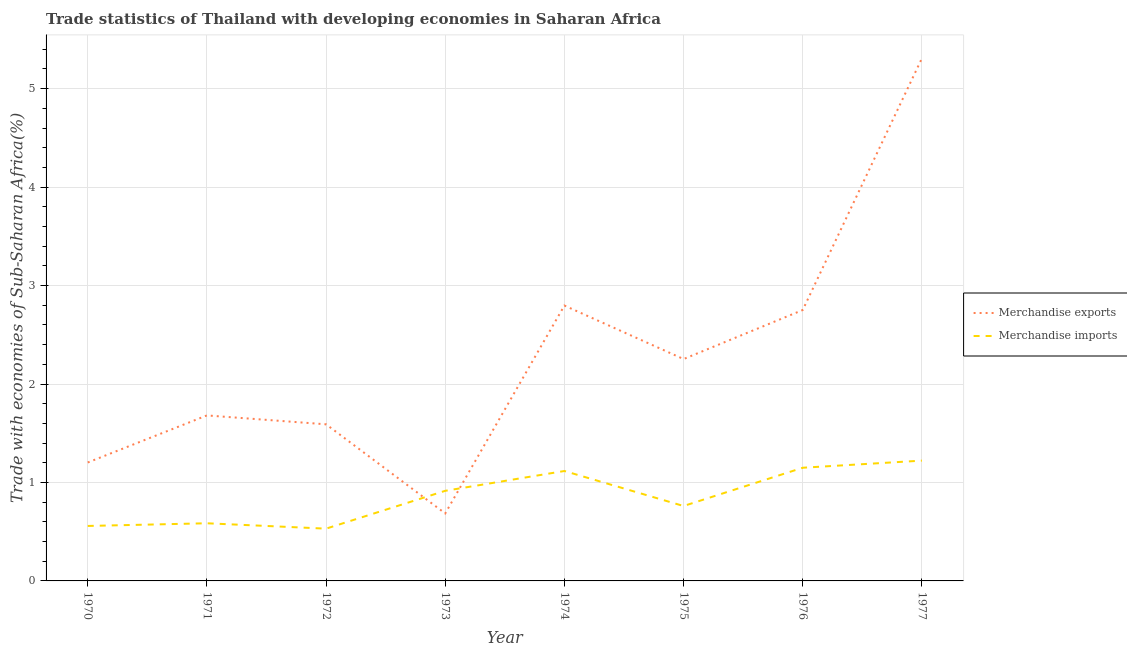How many different coloured lines are there?
Give a very brief answer. 2. Is the number of lines equal to the number of legend labels?
Your answer should be compact. Yes. What is the merchandise imports in 1970?
Ensure brevity in your answer.  0.56. Across all years, what is the maximum merchandise imports?
Offer a terse response. 1.22. Across all years, what is the minimum merchandise imports?
Your response must be concise. 0.53. In which year was the merchandise imports maximum?
Provide a succinct answer. 1977. What is the total merchandise exports in the graph?
Make the answer very short. 18.27. What is the difference between the merchandise imports in 1973 and that in 1975?
Your response must be concise. 0.15. What is the difference between the merchandise exports in 1976 and the merchandise imports in 1977?
Ensure brevity in your answer.  1.53. What is the average merchandise exports per year?
Your response must be concise. 2.28. In the year 1977, what is the difference between the merchandise imports and merchandise exports?
Offer a terse response. -4.09. In how many years, is the merchandise exports greater than 4 %?
Keep it short and to the point. 1. What is the ratio of the merchandise imports in 1970 to that in 1972?
Offer a terse response. 1.05. Is the merchandise imports in 1974 less than that in 1976?
Provide a short and direct response. Yes. Is the difference between the merchandise imports in 1973 and 1974 greater than the difference between the merchandise exports in 1973 and 1974?
Your answer should be compact. Yes. What is the difference between the highest and the second highest merchandise imports?
Your answer should be very brief. 0.07. What is the difference between the highest and the lowest merchandise exports?
Offer a terse response. 4.62. In how many years, is the merchandise imports greater than the average merchandise imports taken over all years?
Offer a terse response. 4. Does the merchandise imports monotonically increase over the years?
Provide a short and direct response. No. Is the merchandise exports strictly less than the merchandise imports over the years?
Your answer should be compact. No. How many lines are there?
Keep it short and to the point. 2. What is the difference between two consecutive major ticks on the Y-axis?
Make the answer very short. 1. Are the values on the major ticks of Y-axis written in scientific E-notation?
Provide a short and direct response. No. Does the graph contain any zero values?
Provide a short and direct response. No. Does the graph contain grids?
Your response must be concise. Yes. How many legend labels are there?
Offer a very short reply. 2. What is the title of the graph?
Your response must be concise. Trade statistics of Thailand with developing economies in Saharan Africa. What is the label or title of the Y-axis?
Your answer should be very brief. Trade with economies of Sub-Saharan Africa(%). What is the Trade with economies of Sub-Saharan Africa(%) of Merchandise exports in 1970?
Provide a succinct answer. 1.2. What is the Trade with economies of Sub-Saharan Africa(%) of Merchandise imports in 1970?
Keep it short and to the point. 0.56. What is the Trade with economies of Sub-Saharan Africa(%) in Merchandise exports in 1971?
Offer a terse response. 1.68. What is the Trade with economies of Sub-Saharan Africa(%) in Merchandise imports in 1971?
Keep it short and to the point. 0.59. What is the Trade with economies of Sub-Saharan Africa(%) in Merchandise exports in 1972?
Offer a very short reply. 1.59. What is the Trade with economies of Sub-Saharan Africa(%) in Merchandise imports in 1972?
Your answer should be compact. 0.53. What is the Trade with economies of Sub-Saharan Africa(%) of Merchandise exports in 1973?
Your response must be concise. 0.69. What is the Trade with economies of Sub-Saharan Africa(%) of Merchandise imports in 1973?
Ensure brevity in your answer.  0.92. What is the Trade with economies of Sub-Saharan Africa(%) of Merchandise exports in 1974?
Provide a succinct answer. 2.8. What is the Trade with economies of Sub-Saharan Africa(%) in Merchandise imports in 1974?
Ensure brevity in your answer.  1.12. What is the Trade with economies of Sub-Saharan Africa(%) of Merchandise exports in 1975?
Ensure brevity in your answer.  2.25. What is the Trade with economies of Sub-Saharan Africa(%) of Merchandise imports in 1975?
Give a very brief answer. 0.76. What is the Trade with economies of Sub-Saharan Africa(%) of Merchandise exports in 1976?
Provide a succinct answer. 2.75. What is the Trade with economies of Sub-Saharan Africa(%) of Merchandise imports in 1976?
Provide a short and direct response. 1.15. What is the Trade with economies of Sub-Saharan Africa(%) of Merchandise exports in 1977?
Make the answer very short. 5.31. What is the Trade with economies of Sub-Saharan Africa(%) of Merchandise imports in 1977?
Your response must be concise. 1.22. Across all years, what is the maximum Trade with economies of Sub-Saharan Africa(%) of Merchandise exports?
Your response must be concise. 5.31. Across all years, what is the maximum Trade with economies of Sub-Saharan Africa(%) in Merchandise imports?
Provide a short and direct response. 1.22. Across all years, what is the minimum Trade with economies of Sub-Saharan Africa(%) in Merchandise exports?
Your answer should be compact. 0.69. Across all years, what is the minimum Trade with economies of Sub-Saharan Africa(%) in Merchandise imports?
Give a very brief answer. 0.53. What is the total Trade with economies of Sub-Saharan Africa(%) in Merchandise exports in the graph?
Provide a short and direct response. 18.27. What is the total Trade with economies of Sub-Saharan Africa(%) in Merchandise imports in the graph?
Your response must be concise. 6.84. What is the difference between the Trade with economies of Sub-Saharan Africa(%) in Merchandise exports in 1970 and that in 1971?
Keep it short and to the point. -0.48. What is the difference between the Trade with economies of Sub-Saharan Africa(%) of Merchandise imports in 1970 and that in 1971?
Offer a very short reply. -0.03. What is the difference between the Trade with economies of Sub-Saharan Africa(%) of Merchandise exports in 1970 and that in 1972?
Your answer should be compact. -0.39. What is the difference between the Trade with economies of Sub-Saharan Africa(%) of Merchandise imports in 1970 and that in 1972?
Keep it short and to the point. 0.03. What is the difference between the Trade with economies of Sub-Saharan Africa(%) in Merchandise exports in 1970 and that in 1973?
Your answer should be compact. 0.52. What is the difference between the Trade with economies of Sub-Saharan Africa(%) of Merchandise imports in 1970 and that in 1973?
Offer a terse response. -0.36. What is the difference between the Trade with economies of Sub-Saharan Africa(%) of Merchandise exports in 1970 and that in 1974?
Your answer should be very brief. -1.59. What is the difference between the Trade with economies of Sub-Saharan Africa(%) in Merchandise imports in 1970 and that in 1974?
Provide a short and direct response. -0.56. What is the difference between the Trade with economies of Sub-Saharan Africa(%) in Merchandise exports in 1970 and that in 1975?
Your response must be concise. -1.05. What is the difference between the Trade with economies of Sub-Saharan Africa(%) in Merchandise imports in 1970 and that in 1975?
Provide a succinct answer. -0.2. What is the difference between the Trade with economies of Sub-Saharan Africa(%) of Merchandise exports in 1970 and that in 1976?
Offer a terse response. -1.55. What is the difference between the Trade with economies of Sub-Saharan Africa(%) of Merchandise imports in 1970 and that in 1976?
Your response must be concise. -0.59. What is the difference between the Trade with economies of Sub-Saharan Africa(%) in Merchandise exports in 1970 and that in 1977?
Your response must be concise. -4.1. What is the difference between the Trade with economies of Sub-Saharan Africa(%) of Merchandise imports in 1970 and that in 1977?
Offer a terse response. -0.66. What is the difference between the Trade with economies of Sub-Saharan Africa(%) of Merchandise exports in 1971 and that in 1972?
Provide a short and direct response. 0.09. What is the difference between the Trade with economies of Sub-Saharan Africa(%) in Merchandise imports in 1971 and that in 1972?
Your answer should be very brief. 0.05. What is the difference between the Trade with economies of Sub-Saharan Africa(%) in Merchandise imports in 1971 and that in 1973?
Ensure brevity in your answer.  -0.33. What is the difference between the Trade with economies of Sub-Saharan Africa(%) in Merchandise exports in 1971 and that in 1974?
Offer a very short reply. -1.12. What is the difference between the Trade with economies of Sub-Saharan Africa(%) in Merchandise imports in 1971 and that in 1974?
Your response must be concise. -0.53. What is the difference between the Trade with economies of Sub-Saharan Africa(%) of Merchandise exports in 1971 and that in 1975?
Ensure brevity in your answer.  -0.57. What is the difference between the Trade with economies of Sub-Saharan Africa(%) of Merchandise imports in 1971 and that in 1975?
Keep it short and to the point. -0.18. What is the difference between the Trade with economies of Sub-Saharan Africa(%) in Merchandise exports in 1971 and that in 1976?
Provide a succinct answer. -1.07. What is the difference between the Trade with economies of Sub-Saharan Africa(%) in Merchandise imports in 1971 and that in 1976?
Your answer should be compact. -0.56. What is the difference between the Trade with economies of Sub-Saharan Africa(%) of Merchandise exports in 1971 and that in 1977?
Ensure brevity in your answer.  -3.63. What is the difference between the Trade with economies of Sub-Saharan Africa(%) in Merchandise imports in 1971 and that in 1977?
Offer a very short reply. -0.64. What is the difference between the Trade with economies of Sub-Saharan Africa(%) of Merchandise exports in 1972 and that in 1973?
Offer a very short reply. 0.91. What is the difference between the Trade with economies of Sub-Saharan Africa(%) in Merchandise imports in 1972 and that in 1973?
Offer a terse response. -0.38. What is the difference between the Trade with economies of Sub-Saharan Africa(%) of Merchandise exports in 1972 and that in 1974?
Offer a very short reply. -1.21. What is the difference between the Trade with economies of Sub-Saharan Africa(%) in Merchandise imports in 1972 and that in 1974?
Offer a very short reply. -0.59. What is the difference between the Trade with economies of Sub-Saharan Africa(%) in Merchandise exports in 1972 and that in 1975?
Ensure brevity in your answer.  -0.66. What is the difference between the Trade with economies of Sub-Saharan Africa(%) of Merchandise imports in 1972 and that in 1975?
Give a very brief answer. -0.23. What is the difference between the Trade with economies of Sub-Saharan Africa(%) in Merchandise exports in 1972 and that in 1976?
Provide a short and direct response. -1.16. What is the difference between the Trade with economies of Sub-Saharan Africa(%) in Merchandise imports in 1972 and that in 1976?
Provide a short and direct response. -0.62. What is the difference between the Trade with economies of Sub-Saharan Africa(%) in Merchandise exports in 1972 and that in 1977?
Provide a short and direct response. -3.72. What is the difference between the Trade with economies of Sub-Saharan Africa(%) of Merchandise imports in 1972 and that in 1977?
Your answer should be very brief. -0.69. What is the difference between the Trade with economies of Sub-Saharan Africa(%) in Merchandise exports in 1973 and that in 1974?
Provide a succinct answer. -2.11. What is the difference between the Trade with economies of Sub-Saharan Africa(%) in Merchandise imports in 1973 and that in 1974?
Provide a succinct answer. -0.2. What is the difference between the Trade with economies of Sub-Saharan Africa(%) in Merchandise exports in 1973 and that in 1975?
Provide a succinct answer. -1.57. What is the difference between the Trade with economies of Sub-Saharan Africa(%) of Merchandise imports in 1973 and that in 1975?
Offer a very short reply. 0.15. What is the difference between the Trade with economies of Sub-Saharan Africa(%) of Merchandise exports in 1973 and that in 1976?
Offer a very short reply. -2.07. What is the difference between the Trade with economies of Sub-Saharan Africa(%) of Merchandise imports in 1973 and that in 1976?
Provide a succinct answer. -0.23. What is the difference between the Trade with economies of Sub-Saharan Africa(%) of Merchandise exports in 1973 and that in 1977?
Provide a succinct answer. -4.62. What is the difference between the Trade with economies of Sub-Saharan Africa(%) of Merchandise imports in 1973 and that in 1977?
Give a very brief answer. -0.31. What is the difference between the Trade with economies of Sub-Saharan Africa(%) of Merchandise exports in 1974 and that in 1975?
Provide a short and direct response. 0.54. What is the difference between the Trade with economies of Sub-Saharan Africa(%) in Merchandise imports in 1974 and that in 1975?
Provide a short and direct response. 0.36. What is the difference between the Trade with economies of Sub-Saharan Africa(%) in Merchandise exports in 1974 and that in 1976?
Keep it short and to the point. 0.05. What is the difference between the Trade with economies of Sub-Saharan Africa(%) of Merchandise imports in 1974 and that in 1976?
Ensure brevity in your answer.  -0.03. What is the difference between the Trade with economies of Sub-Saharan Africa(%) in Merchandise exports in 1974 and that in 1977?
Ensure brevity in your answer.  -2.51. What is the difference between the Trade with economies of Sub-Saharan Africa(%) in Merchandise imports in 1974 and that in 1977?
Provide a succinct answer. -0.11. What is the difference between the Trade with economies of Sub-Saharan Africa(%) in Merchandise exports in 1975 and that in 1976?
Keep it short and to the point. -0.5. What is the difference between the Trade with economies of Sub-Saharan Africa(%) in Merchandise imports in 1975 and that in 1976?
Keep it short and to the point. -0.39. What is the difference between the Trade with economies of Sub-Saharan Africa(%) of Merchandise exports in 1975 and that in 1977?
Offer a terse response. -3.05. What is the difference between the Trade with economies of Sub-Saharan Africa(%) in Merchandise imports in 1975 and that in 1977?
Provide a succinct answer. -0.46. What is the difference between the Trade with economies of Sub-Saharan Africa(%) of Merchandise exports in 1976 and that in 1977?
Your answer should be compact. -2.56. What is the difference between the Trade with economies of Sub-Saharan Africa(%) in Merchandise imports in 1976 and that in 1977?
Ensure brevity in your answer.  -0.07. What is the difference between the Trade with economies of Sub-Saharan Africa(%) in Merchandise exports in 1970 and the Trade with economies of Sub-Saharan Africa(%) in Merchandise imports in 1971?
Give a very brief answer. 0.62. What is the difference between the Trade with economies of Sub-Saharan Africa(%) in Merchandise exports in 1970 and the Trade with economies of Sub-Saharan Africa(%) in Merchandise imports in 1972?
Provide a short and direct response. 0.67. What is the difference between the Trade with economies of Sub-Saharan Africa(%) of Merchandise exports in 1970 and the Trade with economies of Sub-Saharan Africa(%) of Merchandise imports in 1973?
Ensure brevity in your answer.  0.29. What is the difference between the Trade with economies of Sub-Saharan Africa(%) of Merchandise exports in 1970 and the Trade with economies of Sub-Saharan Africa(%) of Merchandise imports in 1974?
Offer a terse response. 0.09. What is the difference between the Trade with economies of Sub-Saharan Africa(%) of Merchandise exports in 1970 and the Trade with economies of Sub-Saharan Africa(%) of Merchandise imports in 1975?
Provide a succinct answer. 0.44. What is the difference between the Trade with economies of Sub-Saharan Africa(%) of Merchandise exports in 1970 and the Trade with economies of Sub-Saharan Africa(%) of Merchandise imports in 1976?
Provide a short and direct response. 0.05. What is the difference between the Trade with economies of Sub-Saharan Africa(%) of Merchandise exports in 1970 and the Trade with economies of Sub-Saharan Africa(%) of Merchandise imports in 1977?
Provide a short and direct response. -0.02. What is the difference between the Trade with economies of Sub-Saharan Africa(%) in Merchandise exports in 1971 and the Trade with economies of Sub-Saharan Africa(%) in Merchandise imports in 1972?
Your answer should be very brief. 1.15. What is the difference between the Trade with economies of Sub-Saharan Africa(%) of Merchandise exports in 1971 and the Trade with economies of Sub-Saharan Africa(%) of Merchandise imports in 1973?
Make the answer very short. 0.77. What is the difference between the Trade with economies of Sub-Saharan Africa(%) of Merchandise exports in 1971 and the Trade with economies of Sub-Saharan Africa(%) of Merchandise imports in 1974?
Your answer should be compact. 0.56. What is the difference between the Trade with economies of Sub-Saharan Africa(%) of Merchandise exports in 1971 and the Trade with economies of Sub-Saharan Africa(%) of Merchandise imports in 1975?
Your response must be concise. 0.92. What is the difference between the Trade with economies of Sub-Saharan Africa(%) of Merchandise exports in 1971 and the Trade with economies of Sub-Saharan Africa(%) of Merchandise imports in 1976?
Your response must be concise. 0.53. What is the difference between the Trade with economies of Sub-Saharan Africa(%) of Merchandise exports in 1971 and the Trade with economies of Sub-Saharan Africa(%) of Merchandise imports in 1977?
Keep it short and to the point. 0.46. What is the difference between the Trade with economies of Sub-Saharan Africa(%) of Merchandise exports in 1972 and the Trade with economies of Sub-Saharan Africa(%) of Merchandise imports in 1973?
Keep it short and to the point. 0.68. What is the difference between the Trade with economies of Sub-Saharan Africa(%) of Merchandise exports in 1972 and the Trade with economies of Sub-Saharan Africa(%) of Merchandise imports in 1974?
Give a very brief answer. 0.47. What is the difference between the Trade with economies of Sub-Saharan Africa(%) in Merchandise exports in 1972 and the Trade with economies of Sub-Saharan Africa(%) in Merchandise imports in 1975?
Keep it short and to the point. 0.83. What is the difference between the Trade with economies of Sub-Saharan Africa(%) in Merchandise exports in 1972 and the Trade with economies of Sub-Saharan Africa(%) in Merchandise imports in 1976?
Your answer should be very brief. 0.44. What is the difference between the Trade with economies of Sub-Saharan Africa(%) in Merchandise exports in 1972 and the Trade with economies of Sub-Saharan Africa(%) in Merchandise imports in 1977?
Your response must be concise. 0.37. What is the difference between the Trade with economies of Sub-Saharan Africa(%) of Merchandise exports in 1973 and the Trade with economies of Sub-Saharan Africa(%) of Merchandise imports in 1974?
Make the answer very short. -0.43. What is the difference between the Trade with economies of Sub-Saharan Africa(%) in Merchandise exports in 1973 and the Trade with economies of Sub-Saharan Africa(%) in Merchandise imports in 1975?
Provide a short and direct response. -0.08. What is the difference between the Trade with economies of Sub-Saharan Africa(%) of Merchandise exports in 1973 and the Trade with economies of Sub-Saharan Africa(%) of Merchandise imports in 1976?
Your response must be concise. -0.46. What is the difference between the Trade with economies of Sub-Saharan Africa(%) in Merchandise exports in 1973 and the Trade with economies of Sub-Saharan Africa(%) in Merchandise imports in 1977?
Provide a short and direct response. -0.54. What is the difference between the Trade with economies of Sub-Saharan Africa(%) in Merchandise exports in 1974 and the Trade with economies of Sub-Saharan Africa(%) in Merchandise imports in 1975?
Give a very brief answer. 2.04. What is the difference between the Trade with economies of Sub-Saharan Africa(%) of Merchandise exports in 1974 and the Trade with economies of Sub-Saharan Africa(%) of Merchandise imports in 1976?
Provide a succinct answer. 1.65. What is the difference between the Trade with economies of Sub-Saharan Africa(%) in Merchandise exports in 1974 and the Trade with economies of Sub-Saharan Africa(%) in Merchandise imports in 1977?
Offer a very short reply. 1.57. What is the difference between the Trade with economies of Sub-Saharan Africa(%) of Merchandise exports in 1975 and the Trade with economies of Sub-Saharan Africa(%) of Merchandise imports in 1976?
Provide a short and direct response. 1.1. What is the difference between the Trade with economies of Sub-Saharan Africa(%) of Merchandise exports in 1975 and the Trade with economies of Sub-Saharan Africa(%) of Merchandise imports in 1977?
Your response must be concise. 1.03. What is the difference between the Trade with economies of Sub-Saharan Africa(%) in Merchandise exports in 1976 and the Trade with economies of Sub-Saharan Africa(%) in Merchandise imports in 1977?
Your response must be concise. 1.53. What is the average Trade with economies of Sub-Saharan Africa(%) of Merchandise exports per year?
Your answer should be compact. 2.28. What is the average Trade with economies of Sub-Saharan Africa(%) of Merchandise imports per year?
Your answer should be compact. 0.85. In the year 1970, what is the difference between the Trade with economies of Sub-Saharan Africa(%) of Merchandise exports and Trade with economies of Sub-Saharan Africa(%) of Merchandise imports?
Provide a short and direct response. 0.64. In the year 1971, what is the difference between the Trade with economies of Sub-Saharan Africa(%) in Merchandise exports and Trade with economies of Sub-Saharan Africa(%) in Merchandise imports?
Provide a short and direct response. 1.1. In the year 1972, what is the difference between the Trade with economies of Sub-Saharan Africa(%) of Merchandise exports and Trade with economies of Sub-Saharan Africa(%) of Merchandise imports?
Your response must be concise. 1.06. In the year 1973, what is the difference between the Trade with economies of Sub-Saharan Africa(%) of Merchandise exports and Trade with economies of Sub-Saharan Africa(%) of Merchandise imports?
Keep it short and to the point. -0.23. In the year 1974, what is the difference between the Trade with economies of Sub-Saharan Africa(%) of Merchandise exports and Trade with economies of Sub-Saharan Africa(%) of Merchandise imports?
Provide a succinct answer. 1.68. In the year 1975, what is the difference between the Trade with economies of Sub-Saharan Africa(%) of Merchandise exports and Trade with economies of Sub-Saharan Africa(%) of Merchandise imports?
Your response must be concise. 1.49. In the year 1976, what is the difference between the Trade with economies of Sub-Saharan Africa(%) of Merchandise exports and Trade with economies of Sub-Saharan Africa(%) of Merchandise imports?
Provide a succinct answer. 1.6. In the year 1977, what is the difference between the Trade with economies of Sub-Saharan Africa(%) in Merchandise exports and Trade with economies of Sub-Saharan Africa(%) in Merchandise imports?
Make the answer very short. 4.09. What is the ratio of the Trade with economies of Sub-Saharan Africa(%) of Merchandise exports in 1970 to that in 1971?
Your answer should be very brief. 0.72. What is the ratio of the Trade with economies of Sub-Saharan Africa(%) in Merchandise imports in 1970 to that in 1971?
Give a very brief answer. 0.95. What is the ratio of the Trade with economies of Sub-Saharan Africa(%) in Merchandise exports in 1970 to that in 1972?
Your response must be concise. 0.76. What is the ratio of the Trade with economies of Sub-Saharan Africa(%) of Merchandise imports in 1970 to that in 1972?
Your response must be concise. 1.05. What is the ratio of the Trade with economies of Sub-Saharan Africa(%) of Merchandise exports in 1970 to that in 1973?
Your answer should be very brief. 1.75. What is the ratio of the Trade with economies of Sub-Saharan Africa(%) of Merchandise imports in 1970 to that in 1973?
Offer a very short reply. 0.61. What is the ratio of the Trade with economies of Sub-Saharan Africa(%) in Merchandise exports in 1970 to that in 1974?
Make the answer very short. 0.43. What is the ratio of the Trade with economies of Sub-Saharan Africa(%) of Merchandise imports in 1970 to that in 1974?
Your answer should be compact. 0.5. What is the ratio of the Trade with economies of Sub-Saharan Africa(%) in Merchandise exports in 1970 to that in 1975?
Provide a succinct answer. 0.53. What is the ratio of the Trade with economies of Sub-Saharan Africa(%) in Merchandise imports in 1970 to that in 1975?
Offer a terse response. 0.73. What is the ratio of the Trade with economies of Sub-Saharan Africa(%) of Merchandise exports in 1970 to that in 1976?
Your response must be concise. 0.44. What is the ratio of the Trade with economies of Sub-Saharan Africa(%) in Merchandise imports in 1970 to that in 1976?
Keep it short and to the point. 0.49. What is the ratio of the Trade with economies of Sub-Saharan Africa(%) of Merchandise exports in 1970 to that in 1977?
Give a very brief answer. 0.23. What is the ratio of the Trade with economies of Sub-Saharan Africa(%) in Merchandise imports in 1970 to that in 1977?
Provide a succinct answer. 0.46. What is the ratio of the Trade with economies of Sub-Saharan Africa(%) of Merchandise exports in 1971 to that in 1972?
Provide a short and direct response. 1.06. What is the ratio of the Trade with economies of Sub-Saharan Africa(%) in Merchandise imports in 1971 to that in 1972?
Keep it short and to the point. 1.1. What is the ratio of the Trade with economies of Sub-Saharan Africa(%) in Merchandise exports in 1971 to that in 1973?
Your answer should be compact. 2.45. What is the ratio of the Trade with economies of Sub-Saharan Africa(%) in Merchandise imports in 1971 to that in 1973?
Offer a terse response. 0.64. What is the ratio of the Trade with economies of Sub-Saharan Africa(%) in Merchandise exports in 1971 to that in 1974?
Provide a succinct answer. 0.6. What is the ratio of the Trade with economies of Sub-Saharan Africa(%) in Merchandise imports in 1971 to that in 1974?
Ensure brevity in your answer.  0.52. What is the ratio of the Trade with economies of Sub-Saharan Africa(%) of Merchandise exports in 1971 to that in 1975?
Ensure brevity in your answer.  0.75. What is the ratio of the Trade with economies of Sub-Saharan Africa(%) of Merchandise imports in 1971 to that in 1975?
Keep it short and to the point. 0.77. What is the ratio of the Trade with economies of Sub-Saharan Africa(%) in Merchandise exports in 1971 to that in 1976?
Your response must be concise. 0.61. What is the ratio of the Trade with economies of Sub-Saharan Africa(%) in Merchandise imports in 1971 to that in 1976?
Your response must be concise. 0.51. What is the ratio of the Trade with economies of Sub-Saharan Africa(%) of Merchandise exports in 1971 to that in 1977?
Provide a succinct answer. 0.32. What is the ratio of the Trade with economies of Sub-Saharan Africa(%) of Merchandise imports in 1971 to that in 1977?
Make the answer very short. 0.48. What is the ratio of the Trade with economies of Sub-Saharan Africa(%) of Merchandise exports in 1972 to that in 1973?
Offer a terse response. 2.32. What is the ratio of the Trade with economies of Sub-Saharan Africa(%) of Merchandise imports in 1972 to that in 1973?
Keep it short and to the point. 0.58. What is the ratio of the Trade with economies of Sub-Saharan Africa(%) of Merchandise exports in 1972 to that in 1974?
Offer a very short reply. 0.57. What is the ratio of the Trade with economies of Sub-Saharan Africa(%) of Merchandise imports in 1972 to that in 1974?
Provide a succinct answer. 0.48. What is the ratio of the Trade with economies of Sub-Saharan Africa(%) in Merchandise exports in 1972 to that in 1975?
Offer a very short reply. 0.71. What is the ratio of the Trade with economies of Sub-Saharan Africa(%) of Merchandise imports in 1972 to that in 1975?
Offer a terse response. 0.7. What is the ratio of the Trade with economies of Sub-Saharan Africa(%) of Merchandise exports in 1972 to that in 1976?
Your response must be concise. 0.58. What is the ratio of the Trade with economies of Sub-Saharan Africa(%) in Merchandise imports in 1972 to that in 1976?
Make the answer very short. 0.46. What is the ratio of the Trade with economies of Sub-Saharan Africa(%) in Merchandise exports in 1972 to that in 1977?
Keep it short and to the point. 0.3. What is the ratio of the Trade with economies of Sub-Saharan Africa(%) of Merchandise imports in 1972 to that in 1977?
Provide a succinct answer. 0.43. What is the ratio of the Trade with economies of Sub-Saharan Africa(%) in Merchandise exports in 1973 to that in 1974?
Keep it short and to the point. 0.25. What is the ratio of the Trade with economies of Sub-Saharan Africa(%) in Merchandise imports in 1973 to that in 1974?
Your answer should be very brief. 0.82. What is the ratio of the Trade with economies of Sub-Saharan Africa(%) of Merchandise exports in 1973 to that in 1975?
Provide a succinct answer. 0.3. What is the ratio of the Trade with economies of Sub-Saharan Africa(%) of Merchandise imports in 1973 to that in 1975?
Give a very brief answer. 1.2. What is the ratio of the Trade with economies of Sub-Saharan Africa(%) in Merchandise exports in 1973 to that in 1976?
Provide a succinct answer. 0.25. What is the ratio of the Trade with economies of Sub-Saharan Africa(%) of Merchandise imports in 1973 to that in 1976?
Your response must be concise. 0.8. What is the ratio of the Trade with economies of Sub-Saharan Africa(%) of Merchandise exports in 1973 to that in 1977?
Your answer should be compact. 0.13. What is the ratio of the Trade with economies of Sub-Saharan Africa(%) of Merchandise imports in 1973 to that in 1977?
Provide a short and direct response. 0.75. What is the ratio of the Trade with economies of Sub-Saharan Africa(%) of Merchandise exports in 1974 to that in 1975?
Give a very brief answer. 1.24. What is the ratio of the Trade with economies of Sub-Saharan Africa(%) of Merchandise imports in 1974 to that in 1975?
Make the answer very short. 1.47. What is the ratio of the Trade with economies of Sub-Saharan Africa(%) of Merchandise exports in 1974 to that in 1976?
Your answer should be compact. 1.02. What is the ratio of the Trade with economies of Sub-Saharan Africa(%) of Merchandise imports in 1974 to that in 1976?
Provide a succinct answer. 0.97. What is the ratio of the Trade with economies of Sub-Saharan Africa(%) in Merchandise exports in 1974 to that in 1977?
Your answer should be compact. 0.53. What is the ratio of the Trade with economies of Sub-Saharan Africa(%) of Merchandise imports in 1974 to that in 1977?
Offer a terse response. 0.91. What is the ratio of the Trade with economies of Sub-Saharan Africa(%) in Merchandise exports in 1975 to that in 1976?
Your response must be concise. 0.82. What is the ratio of the Trade with economies of Sub-Saharan Africa(%) in Merchandise imports in 1975 to that in 1976?
Keep it short and to the point. 0.66. What is the ratio of the Trade with economies of Sub-Saharan Africa(%) of Merchandise exports in 1975 to that in 1977?
Provide a short and direct response. 0.42. What is the ratio of the Trade with economies of Sub-Saharan Africa(%) in Merchandise imports in 1975 to that in 1977?
Ensure brevity in your answer.  0.62. What is the ratio of the Trade with economies of Sub-Saharan Africa(%) of Merchandise exports in 1976 to that in 1977?
Offer a terse response. 0.52. What is the ratio of the Trade with economies of Sub-Saharan Africa(%) in Merchandise imports in 1976 to that in 1977?
Ensure brevity in your answer.  0.94. What is the difference between the highest and the second highest Trade with economies of Sub-Saharan Africa(%) of Merchandise exports?
Provide a succinct answer. 2.51. What is the difference between the highest and the second highest Trade with economies of Sub-Saharan Africa(%) in Merchandise imports?
Offer a very short reply. 0.07. What is the difference between the highest and the lowest Trade with economies of Sub-Saharan Africa(%) of Merchandise exports?
Offer a terse response. 4.62. What is the difference between the highest and the lowest Trade with economies of Sub-Saharan Africa(%) of Merchandise imports?
Offer a very short reply. 0.69. 